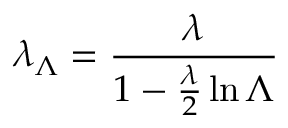<formula> <loc_0><loc_0><loc_500><loc_500>\lambda _ { \Lambda } = { \frac { \lambda } { 1 - { \frac { \lambda } { 2 } } \ln \Lambda } }</formula> 